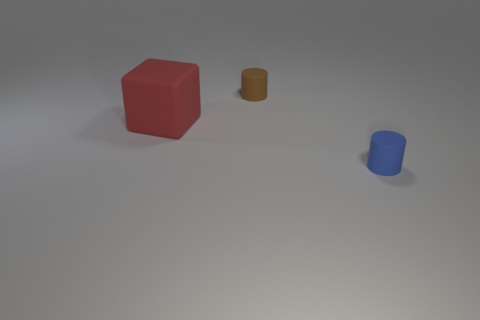Add 3 red rubber objects. How many objects exist? 6 Subtract all cubes. How many objects are left? 2 Subtract 0 gray cubes. How many objects are left? 3 Subtract all big objects. Subtract all large things. How many objects are left? 1 Add 1 tiny cylinders. How many tiny cylinders are left? 3 Add 2 rubber things. How many rubber things exist? 5 